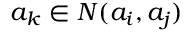Convert formula to latex. <formula><loc_0><loc_0><loc_500><loc_500>a _ { k } \in N ( a _ { i } , a _ { j } )</formula> 